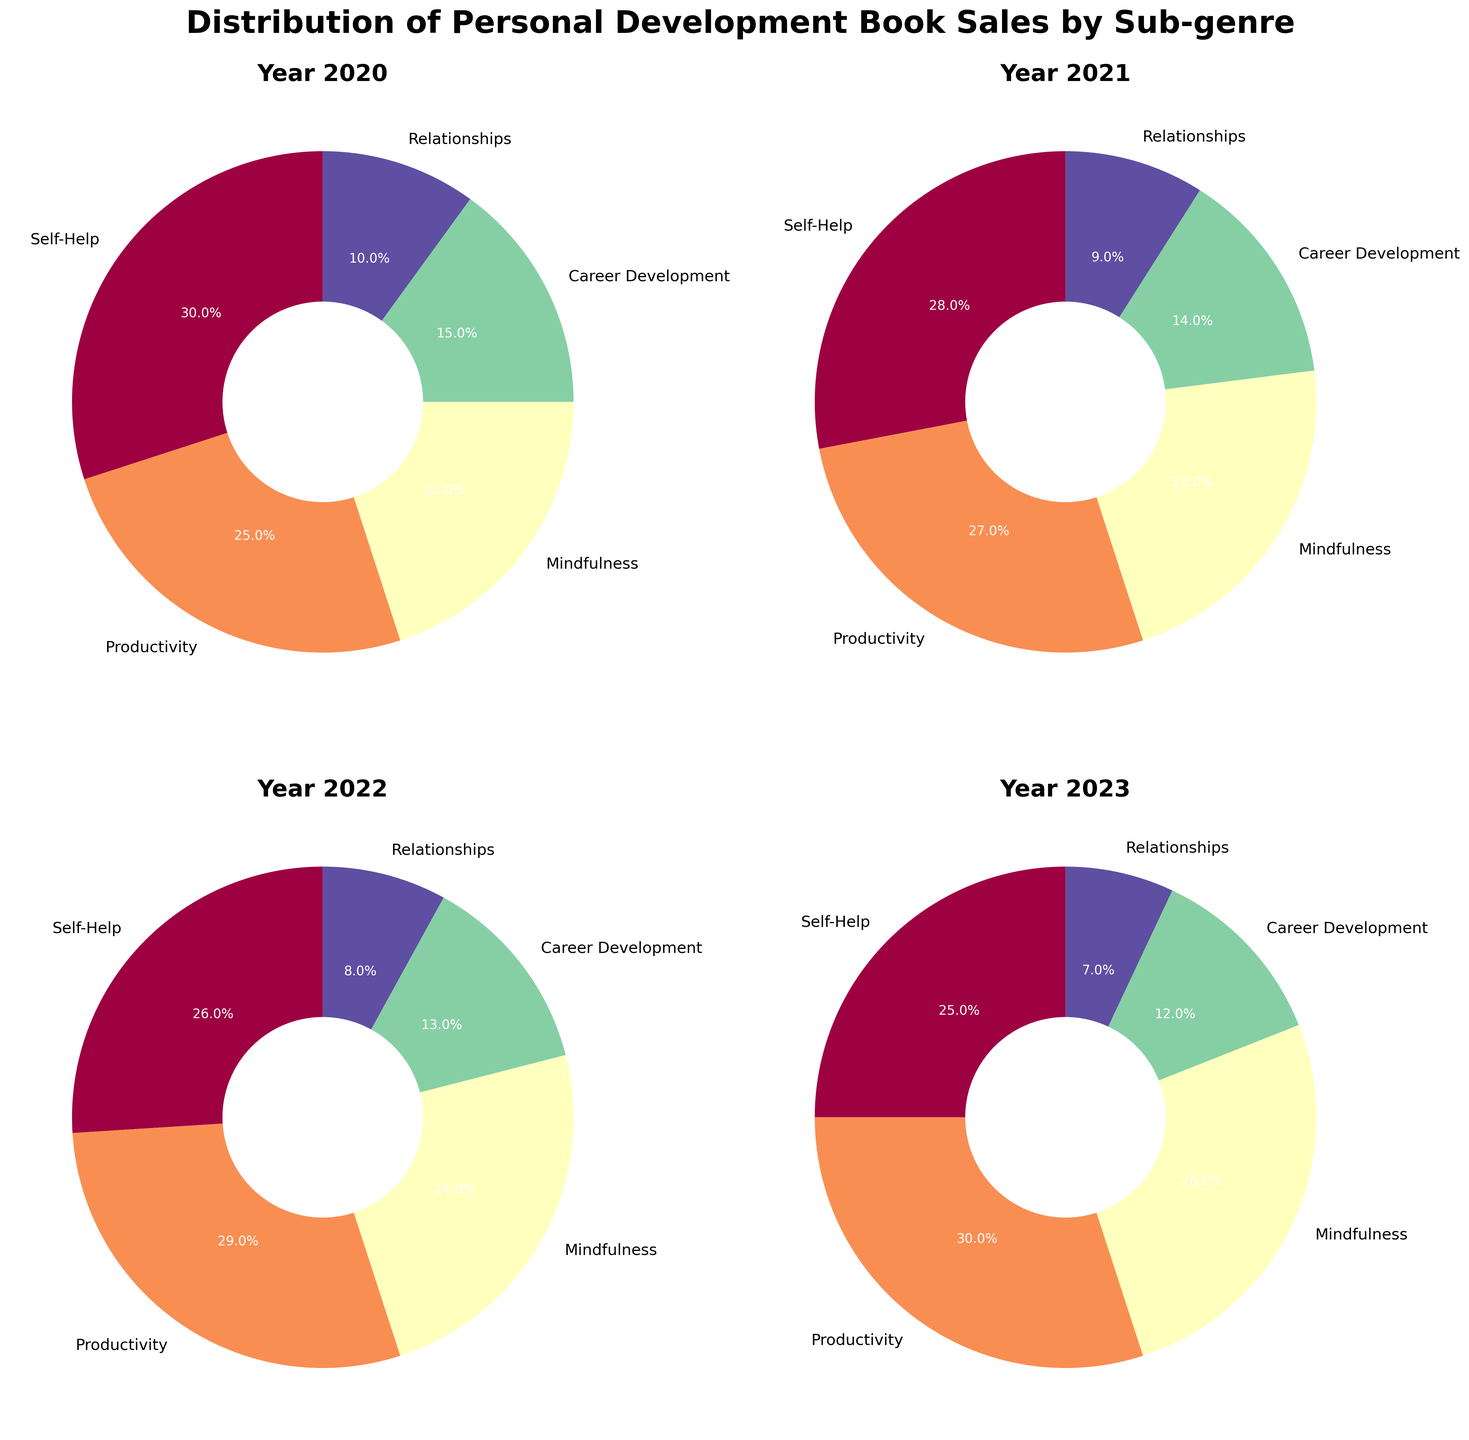Which sub-genre had the highest percentage of sales in 2023? Look at the 2023 pie chart and identify the sub-genre with the largest slice. The Productivity sub-genre has the highest percentage.
Answer: Productivity Which sub-genre's sales percentage decreased the most from 2020 to 2023? Compare the percentages for each sub-genre from 2020 to 2023. The sub-genre "Self-Help" decreased from 30% in 2020 to 25% in 2023, making it the largest decrease of 5%.
Answer: Self-Help Between 2020 and 2022, which sub-genre saw the greatest overall increase in sales percentage? Analyze the pie charts for 2020 and 2022. The Productivity sub-genre increased from 25% in 2020 to 29% in 2022, a total increase of 4%.
Answer: Productivity How does the percentage of sales for the Mindfulness sub-genre in 2021 compare with that in 2023? Compare the Mindfulness sub-genre percentages in 2021 (22%) and 2023 (26%). In 2023, the percentage is higher by 4%.
Answer: 4% higher Which two years had the highest and lowest sales percentages for the Relationships sub-genre, respectively? Look at the pie charts for all years and compare the Relationships sub-genre. 2020 had the highest percentage (10%), and 2023 had the lowest (7%).
Answer: 2020 and 2023 What is the average sales percentage of the Career Development sub-genre from 2020 to 2023? Add up the percentages of Career Development over the years (15% + 14% + 13% + 12%) and divide by 4. The average is (15+14+13+12)/4 = 13.5%.
Answer: 13.5% Between 2022 and 2023, which sub-genre had an increase in sales percentage? Compare the pie charts for 2022 and 2023. The Mindfulness sub-genre increased from 24% to 26%, and the Productivity sub-genre increased from 29% to 30%.
Answer: Mindfulness, Productivity Which sub-genre consistently decreased in sales percentage each year from 2020 to 2023? Examine each year’s pie chart and track the sub-genre percentages. The Relationships sub-genre consistently decreased from 10% in 2020 to 7% in 2023.
Answer: Relationships Comparing 2021 and 2023, which sub-genre had its percentage cut by more than half? Look at percentages for each sub-genre in 2021 and 2023. None of the sub-genres had their percentages cut by more than half in this period.
Answer: None 